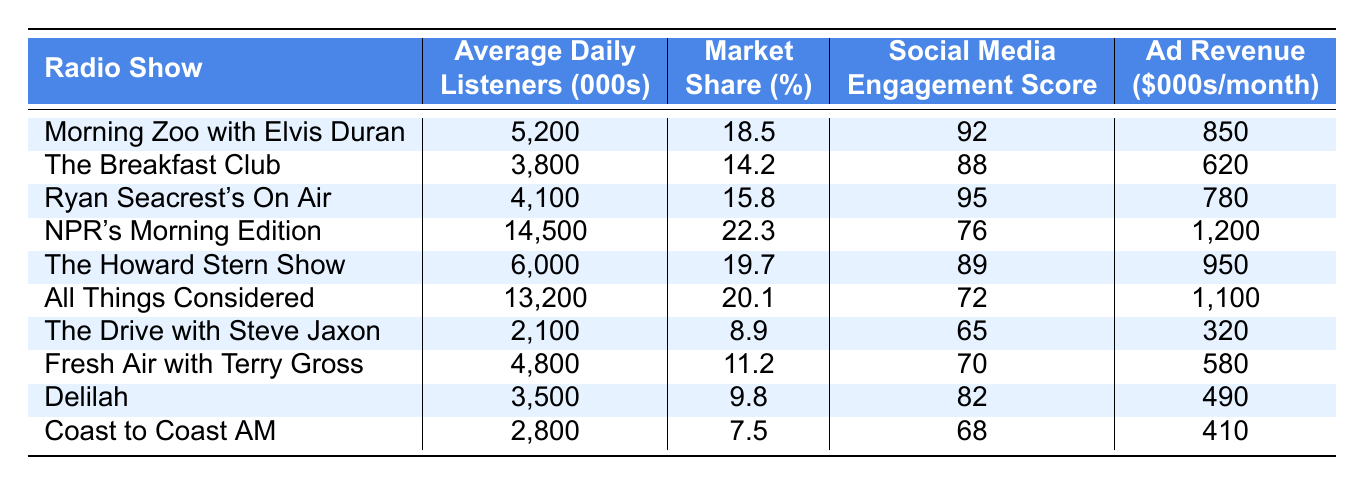What are the average daily listeners for NPR's Morning Edition? The table shows that NPR's Morning Edition has 14,500 average daily listeners (in thousands).
Answer: 14,500 Which show has the highest market share? To determine the highest market share, we look for the maximum percentage in the "Market Share (%)" column. NPR's Morning Edition has the highest market share at 22.3%.
Answer: 22.3% What is the social media engagement score for The Breakfast Club? The table indicates that The Breakfast Club has a social media engagement score of 88.
Answer: 88 Which show has the lowest average daily listeners? By comparing the values in the "Average Daily Listeners (000s)" column, The Drive with Steve Jaxon has the lowest at 2,100.
Answer: 2,100 Is the ad revenue for The Howard Stern Show greater than 900? The table lists The Howard Stern Show's ad revenue as 950, which is greater than 900.
Answer: Yes What is the difference in average daily listeners between NPR's Morning Edition and All Things Considered? NPR's Morning Edition has 14,500 listeners while All Things Considered has 13,200. The difference is 14,500 - 13,200 = 1,300.
Answer: 1,300 Which show has a social media engagement score above 90? Looking at the "Social Media Engagement Score" column, only NPR's Morning Edition (score of 76) and Ryan Seacrest's On Air (score of 95) have this information. Among them, only Ryan Seacrest's On Air exceeds 90.
Answer: Ryan Seacrest's On Air What is the total ad revenue of all morning shows listed? The morning shows listed are: Morning Zoo with Elvis Duran, The Breakfast Club, Ryan Seacrest's On Air, NPR's Morning Edition, The Howard Stern Show, and All Things Considered. Their respective ad revenues are 850, 620, 780, 1200, 950, and 1100. Adding these gives 850 + 620 + 780 + 1200 + 950 + 1100 = 4600.
Answer: 4,600 Is it true that the average daily listeners for Coast to Coast AM are lower than 3,000? Coast to Coast AM has 2,800 average daily listeners, which is indeed lower than 3,000.
Answer: Yes If we consider the shows with average daily listeners over 5,000, how many shows fit this criterion? The shows are NPR's Morning Edition (14,500), All Things Considered (13,200), The Howard Stern Show (6,000), and Morning Zoo with Elvis Duran (5,200). There are four shows fitting this criterion.
Answer: 4 